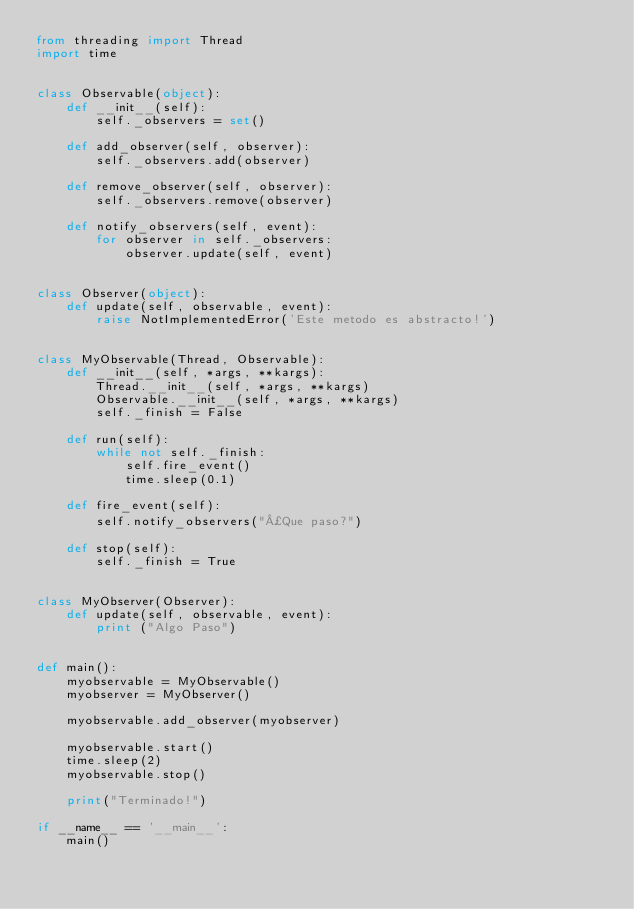Convert code to text. <code><loc_0><loc_0><loc_500><loc_500><_Python_>from threading import Thread
import time


class Observable(object):
    def __init__(self):
        self._observers = set()

    def add_observer(self, observer):
        self._observers.add(observer)

    def remove_observer(self, observer):
        self._observers.remove(observer)

    def notify_observers(self, event):
        for observer in self._observers:
            observer.update(self, event)


class Observer(object):
    def update(self, observable, event):
        raise NotImplementedError('Este metodo es abstracto!')


class MyObservable(Thread, Observable):
    def __init__(self, *args, **kargs):
        Thread.__init__(self, *args, **kargs)
        Observable.__init__(self, *args, **kargs)
        self._finish = False

    def run(self):
        while not self._finish:
            self.fire_event()
            time.sleep(0.1)

    def fire_event(self):
        self.notify_observers("¿Que paso?")

    def stop(self):
        self._finish = True


class MyObserver(Observer):
    def update(self, observable, event):
        print ("Algo Paso")


def main():
    myobservable = MyObservable()
    myobserver = MyObserver()

    myobservable.add_observer(myobserver)

    myobservable.start()
    time.sleep(2)
    myobservable.stop()

    print("Terminado!")

if __name__ == '__main__':
    main()




</code> 